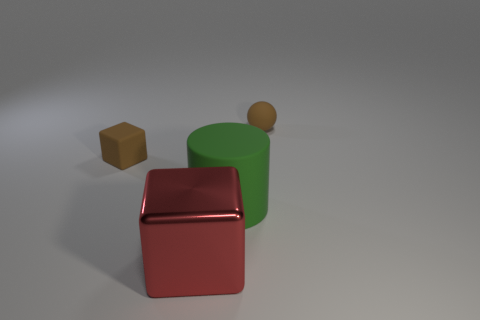Add 2 green cylinders. How many objects exist? 6 Subtract 1 brown balls. How many objects are left? 3 Subtract all spheres. How many objects are left? 3 Subtract all big red metallic things. Subtract all large gray cylinders. How many objects are left? 3 Add 4 metallic blocks. How many metallic blocks are left? 5 Add 1 cyan rubber spheres. How many cyan rubber spheres exist? 1 